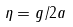Convert formula to latex. <formula><loc_0><loc_0><loc_500><loc_500>\eta = g / 2 a</formula> 